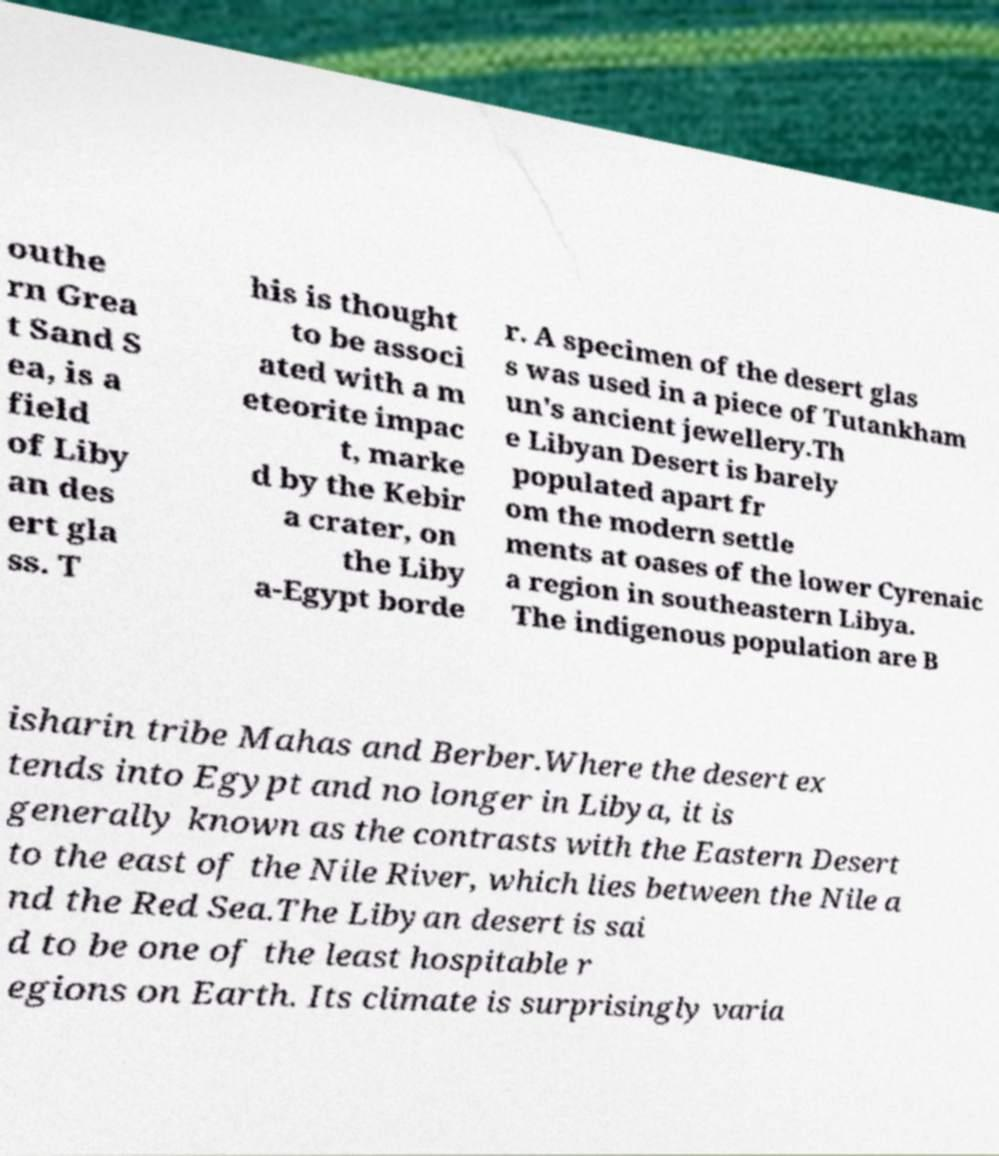Please read and relay the text visible in this image. What does it say? outhe rn Grea t Sand S ea, is a field of Liby an des ert gla ss. T his is thought to be associ ated with a m eteorite impac t, marke d by the Kebir a crater, on the Liby a-Egypt borde r. A specimen of the desert glas s was used in a piece of Tutankham un's ancient jewellery.Th e Libyan Desert is barely populated apart fr om the modern settle ments at oases of the lower Cyrenaic a region in southeastern Libya. The indigenous population are B isharin tribe Mahas and Berber.Where the desert ex tends into Egypt and no longer in Libya, it is generally known as the contrasts with the Eastern Desert to the east of the Nile River, which lies between the Nile a nd the Red Sea.The Libyan desert is sai d to be one of the least hospitable r egions on Earth. Its climate is surprisingly varia 